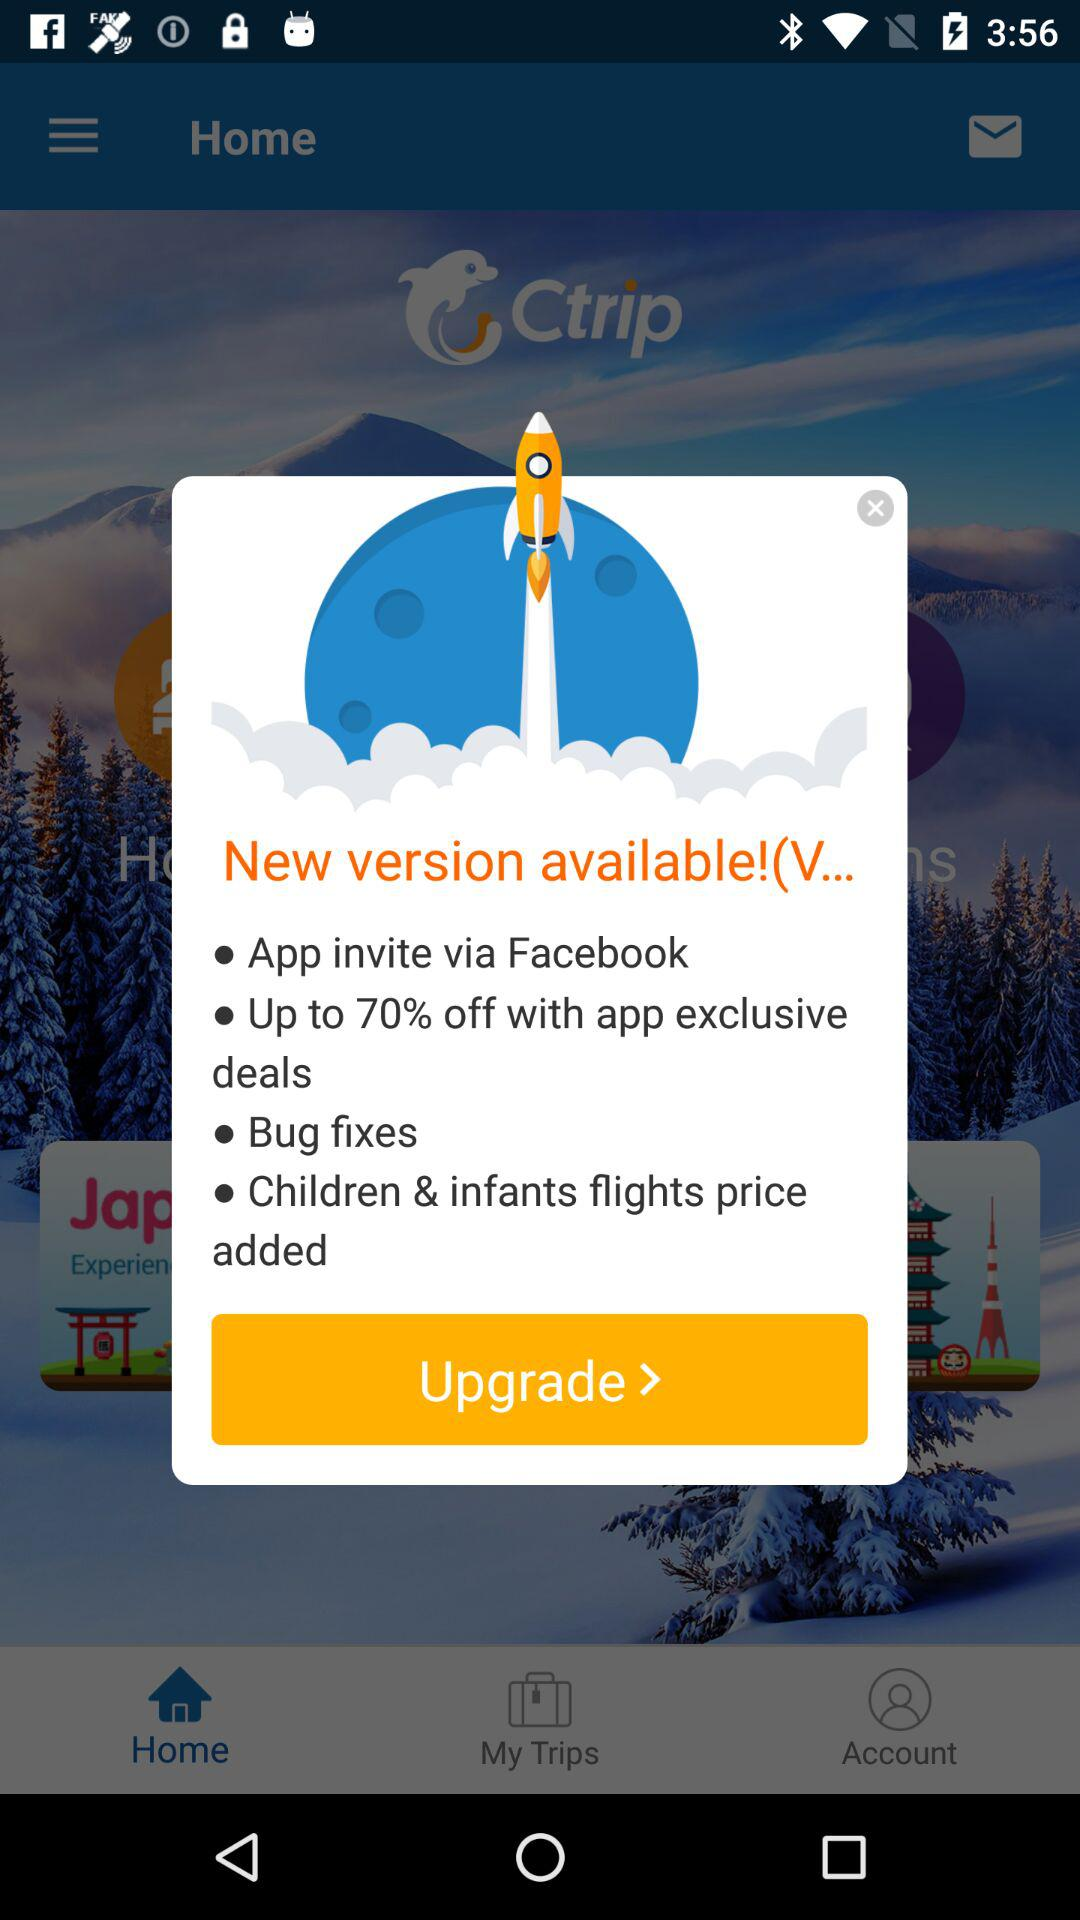What are the new features in the new version? The new features are "App invite via Facebook", "Up to 70% off with app exclusive deals", "Bug fixes" and "Children & infants flights price added". 